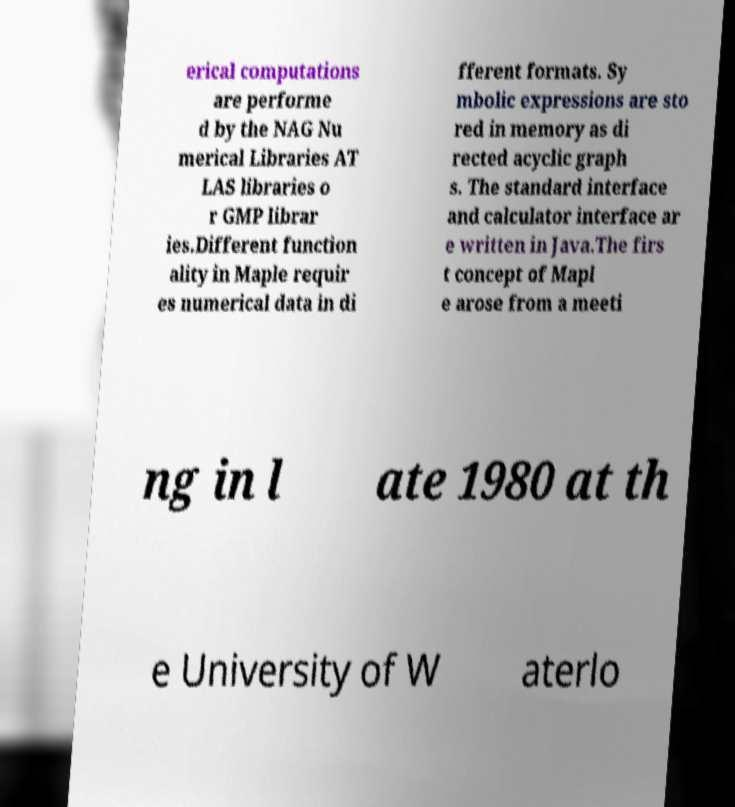There's text embedded in this image that I need extracted. Can you transcribe it verbatim? erical computations are performe d by the NAG Nu merical Libraries AT LAS libraries o r GMP librar ies.Different function ality in Maple requir es numerical data in di fferent formats. Sy mbolic expressions are sto red in memory as di rected acyclic graph s. The standard interface and calculator interface ar e written in Java.The firs t concept of Mapl e arose from a meeti ng in l ate 1980 at th e University of W aterlo 